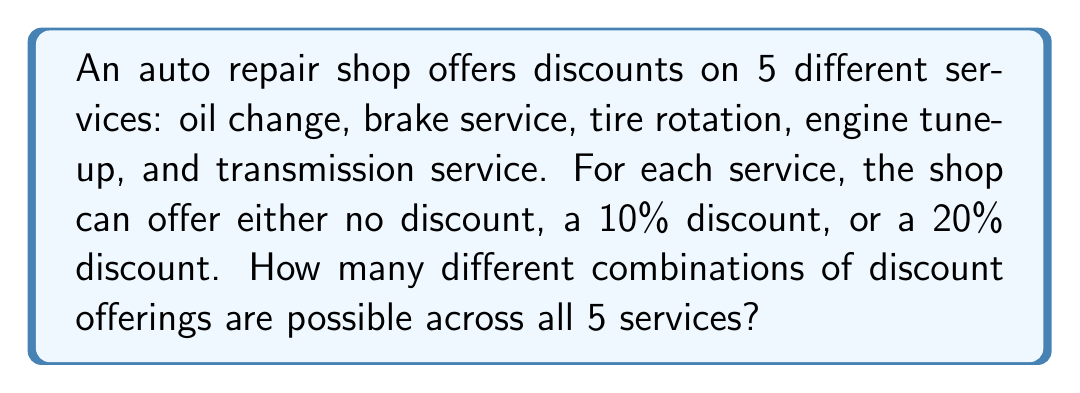Show me your answer to this math problem. Let's approach this step-by-step:

1) For each service, there are 3 possible discount options:
   - No discount
   - 10% discount
   - 20% discount

2) This means for each service, we have 3 choices.

3) We need to determine the total number of ways to choose discounts for all 5 services.

4) This is a perfect scenario for applying the multiplication principle of counting.

5) According to this principle, if we have a series of independent choices, where:
   - There are $m_1$ ways of making the first choice,
   - $m_2$ ways of making the second choice,
   - And so on up to $m_n$ ways of making the nth choice,
   Then the total number of ways to make all these choices is:
   
   $$m_1 \times m_2 \times ... \times m_n$$

6) In our case, we have 5 services, and for each service, we have 3 choices.

7) Therefore, the total number of possible combinations is:

   $$3 \times 3 \times 3 \times 3 \times 3 = 3^5$$

8) Calculate:
   $$3^5 = 3 \times 3 \times 3 \times 3 \times 3 = 243$$

Thus, there are 243 possible combinations of discount offerings across all 5 services.
Answer: 243 